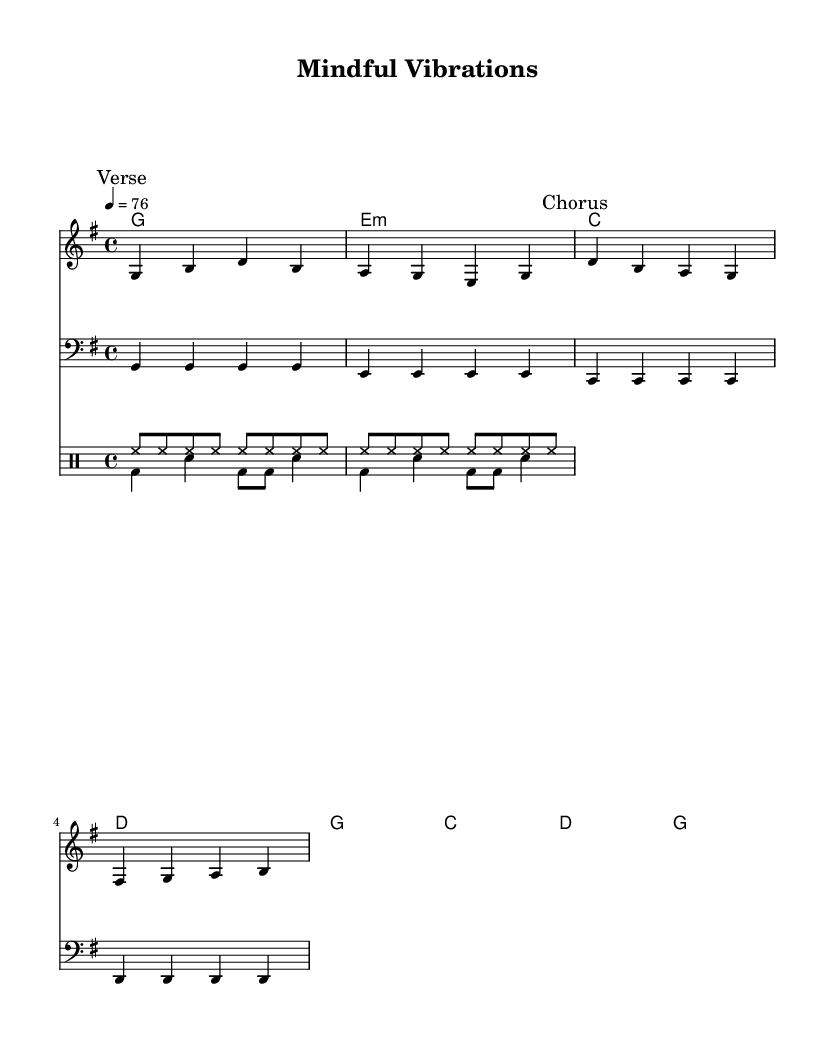What is the key signature of this music? The key signature is G major, which has one sharp (F#). You can determine this by looking at the key indicated at the beginning of the sheet music, where it states "g \major."
Answer: G major What is the time signature of this piece? The time signature is 4/4, meaning there are four beats per measure and a quarter note receives one beat. This can be found at the beginning of the score, next to the key signature.
Answer: 4/4 What is the tempo marking for this piece? The tempo marking is 76 beats per minute (bpm). This is indicated by the instruction "4 = 76" in the global section, which tells musicians how fast to play the piece.
Answer: 76 How many measures are in the melody? There are eight measures in the melody. By counting the measures in the melody staff, which are separated by vertical lines, one can find the total.
Answer: 8 What is the first word of the chorus? The first word of the chorus is "Mind." This can be found in the lyrics section, where the chorus begins after the verse words.
Answer: Mind Which musical genre does this piece belong to? This piece belongs to the Reggae genre, characterized by its rhythmic style and themes often related to social issues and well-being, which is clear from the title and lyrical content.
Answer: Reggae What are the drum parts primarily used in this piece? The drum parts consist of a hi-hat rhythm (repeated eighth notes) and bass drum/snare combinations, which are typical in reggae music to maintain a groove. By examining the notation in the drum staff, the distinct patterns can be observed.
Answer: Hi-hat and bass/snare 